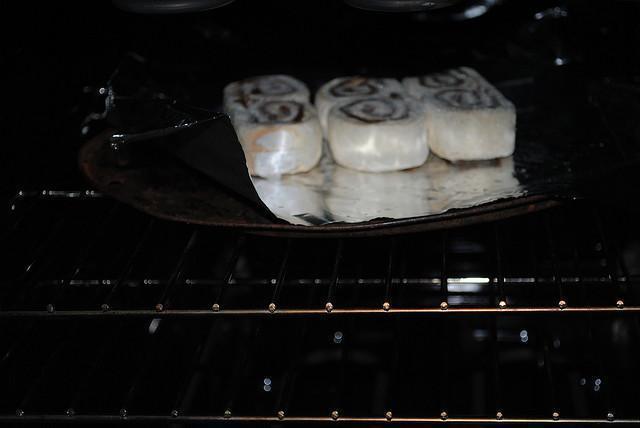Why are the cinnamon buns white?
Make your selection from the four choices given to correctly answer the question.
Options: Food coloring, ranch dressing, mayonnaise, icing. Icing. 